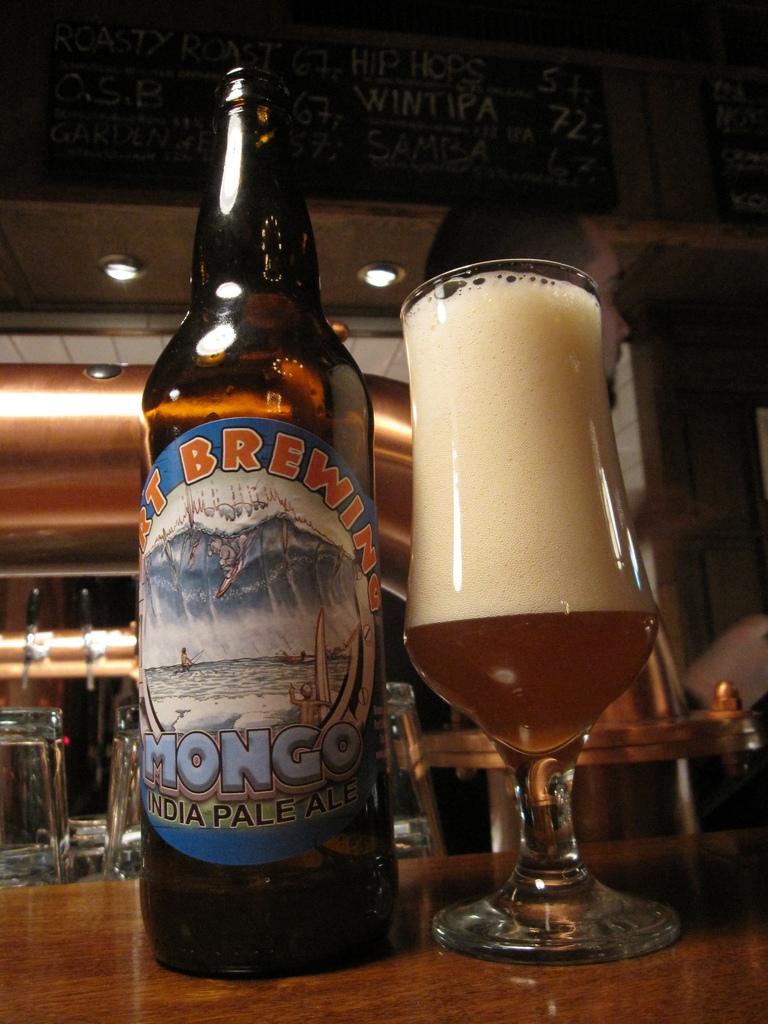What type of beer is in the bottle?
Provide a short and direct response. India pale ale. According to the label, is this a dark or pale ale?
Your answer should be very brief. Pale. 